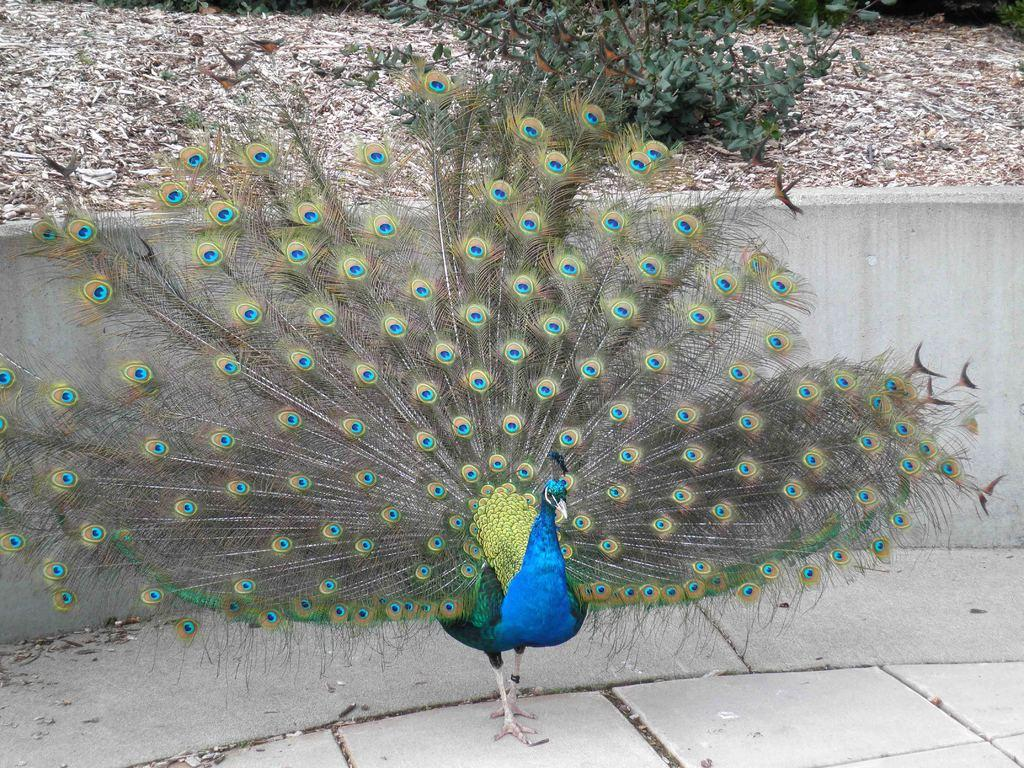What type of animal is in the picture? There is a peacock in the picture. Where is the peacock located in relation to other objects in the image? The peacock is standing near a wall. What can be seen at the top of the image? Plants and leaves are visible at the top of the image. What type of whip is the peacock using to sing a cover in the image? There is no whip or singing in the image; it features a peacock standing near a wall with plants and leaves visible at the top. 